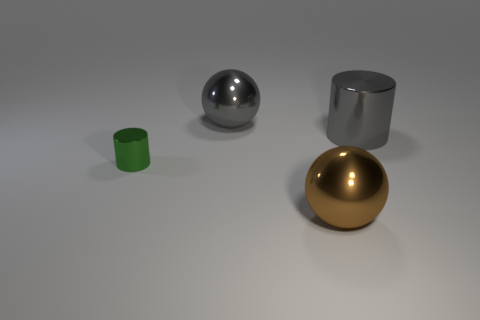What is the shape of the metal thing in front of the green thing?
Ensure brevity in your answer.  Sphere. The other sphere that is the same size as the gray ball is what color?
Your answer should be compact. Brown. There is a object that is both left of the brown sphere and in front of the big gray cylinder; what size is it?
Offer a very short reply. Small. What is the size of the metallic cylinder that is left of the large brown ball?
Offer a terse response. Small. The shiny thing that is the same color as the large cylinder is what shape?
Provide a succinct answer. Sphere. What is the shape of the big gray object that is right of the gray object behind the large gray thing that is to the right of the brown sphere?
Ensure brevity in your answer.  Cylinder. What number of other things are the same shape as the brown metal object?
Offer a terse response. 1. What number of rubber things are small green cylinders or big gray spheres?
Keep it short and to the point. 0. There is a sphere that is in front of the cylinder behind the green metal object; what is it made of?
Provide a succinct answer. Metal. Is the number of large metal objects that are in front of the tiny green metal cylinder greater than the number of tiny green metal blocks?
Offer a terse response. Yes. 